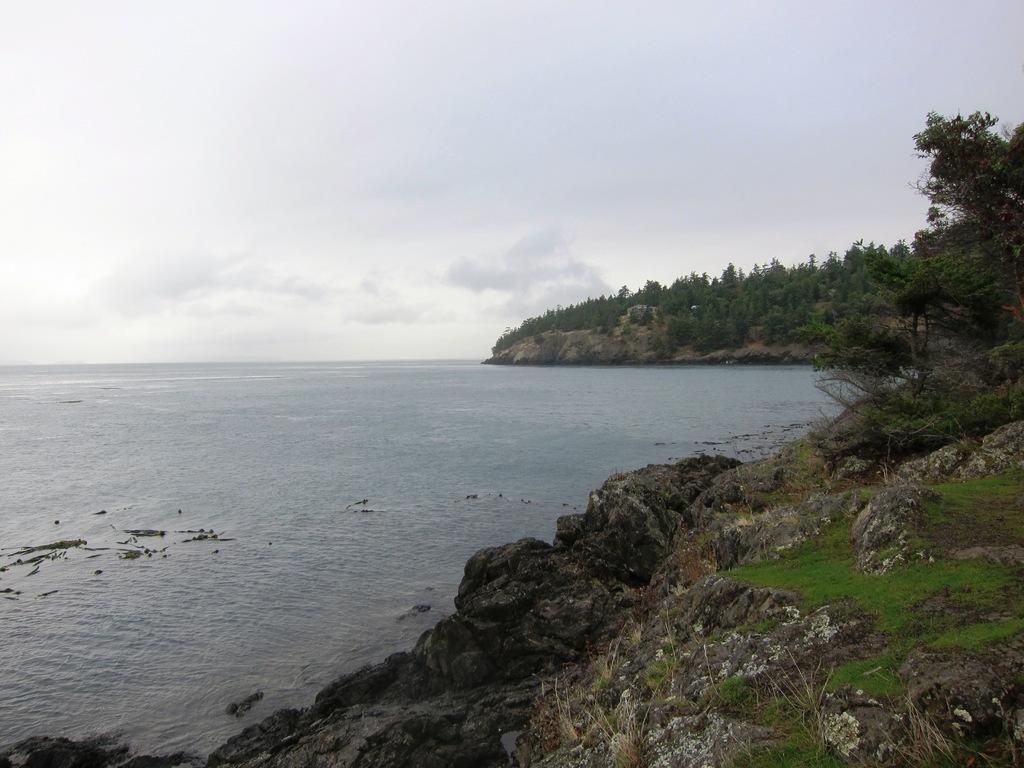In one or two sentences, can you explain what this image depicts? In this image we can see the sea. There are many trees and plants in the image. We can see the cloudy sky in the image. We can see a grassy land at the bottom of the image. 